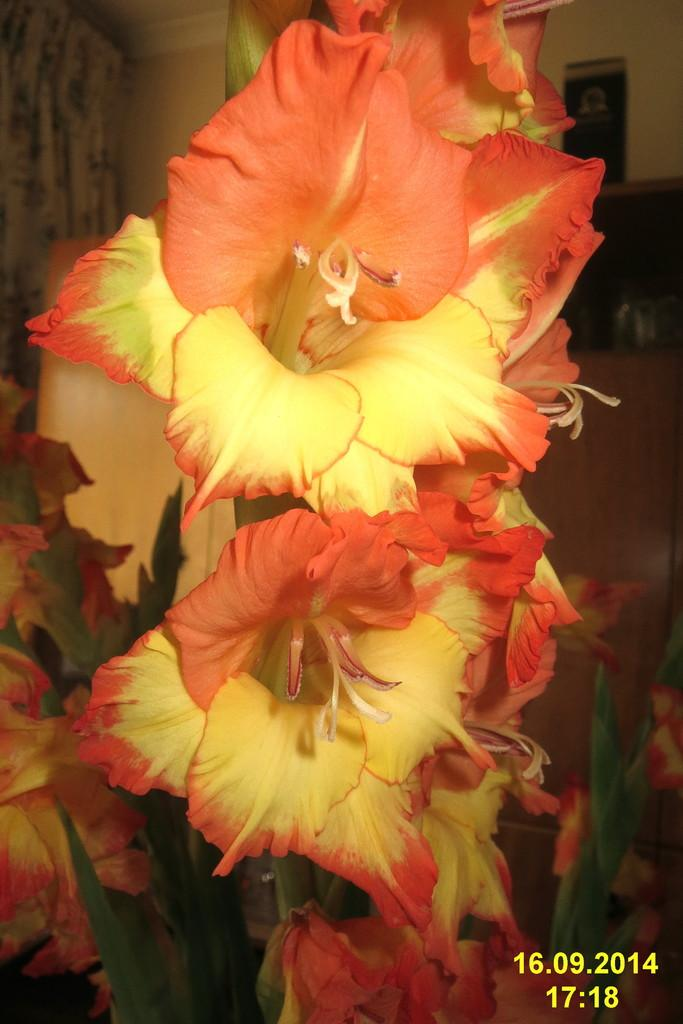What is the main subject in the center of the image? There are flowers in the center of the image. Is there any text present in the image? Yes, there is text on the right side bottom of the image. What type of frame is used to display the flowers in the image? There is no frame visible in the image; it only shows the flowers and text. How many cakes are present in the image? There are no cakes present in the image. 